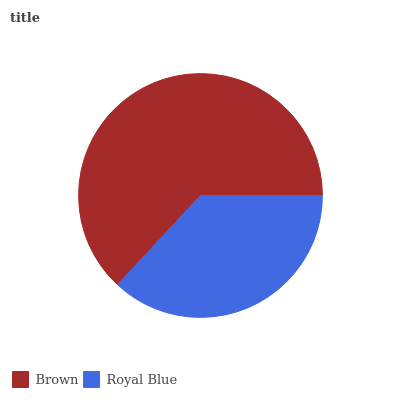Is Royal Blue the minimum?
Answer yes or no. Yes. Is Brown the maximum?
Answer yes or no. Yes. Is Royal Blue the maximum?
Answer yes or no. No. Is Brown greater than Royal Blue?
Answer yes or no. Yes. Is Royal Blue less than Brown?
Answer yes or no. Yes. Is Royal Blue greater than Brown?
Answer yes or no. No. Is Brown less than Royal Blue?
Answer yes or no. No. Is Brown the high median?
Answer yes or no. Yes. Is Royal Blue the low median?
Answer yes or no. Yes. Is Royal Blue the high median?
Answer yes or no. No. Is Brown the low median?
Answer yes or no. No. 